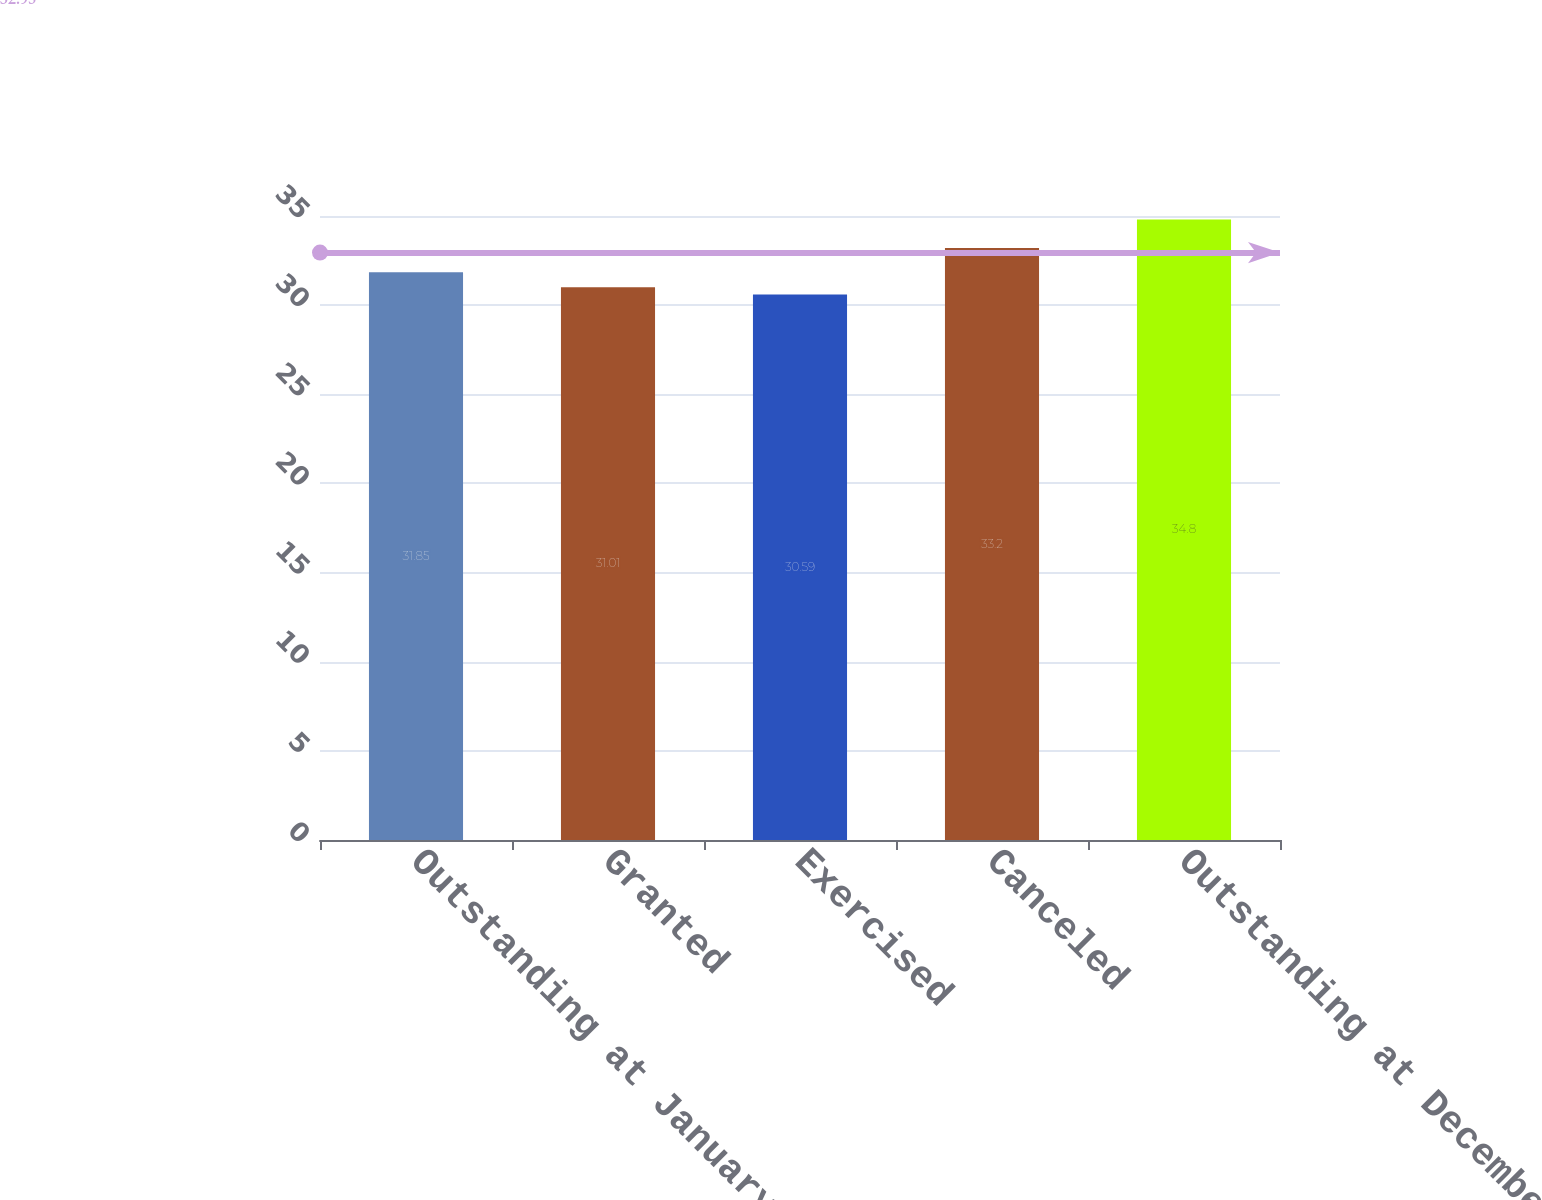<chart> <loc_0><loc_0><loc_500><loc_500><bar_chart><fcel>Outstanding at January 1 2000<fcel>Granted<fcel>Exercised<fcel>Canceled<fcel>Outstanding at December 31<nl><fcel>31.85<fcel>31.01<fcel>30.59<fcel>33.2<fcel>34.8<nl></chart> 